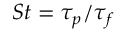Convert formula to latex. <formula><loc_0><loc_0><loc_500><loc_500>S t = \tau _ { p } / \tau _ { f }</formula> 